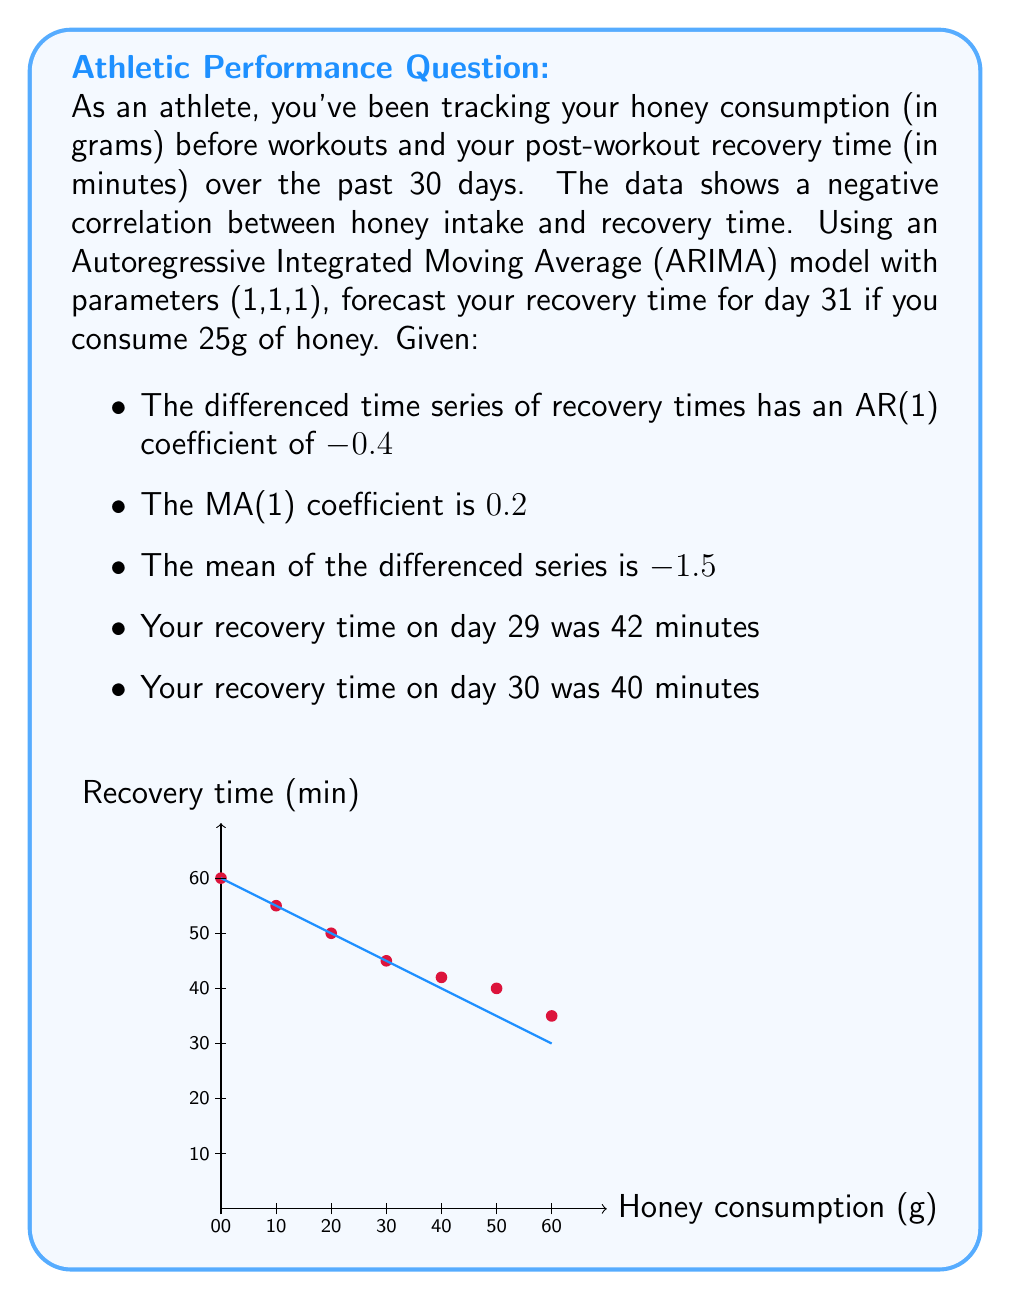Can you solve this math problem? To forecast the recovery time using the ARIMA(1,1,1) model, we'll follow these steps:

1) The general form of an ARIMA(1,1,1) model is:
   $$(1-\phi B)(1-B)y_t = (1+\theta B)\epsilon_t + c$$
   where $\phi$ is the AR(1) coefficient, $\theta$ is the MA(1) coefficient, $B$ is the backshift operator, and $c$ is a constant.

2) Given:
   - AR(1) coefficient $\phi = -0.4$
   - MA(1) coefficient $\theta = 0.2$
   - Mean of differenced series $\mu = -1.5$

3) The constant $c$ is related to the mean of the differenced series:
   $$c = \mu(1-\phi) = -1.5(1-(-0.4)) = -2.1$$

4) Let's denote the recovery time on day $t$ as $y_t$. We need to forecast $y_{31}$.

5) The differenced series is $\nabla y_t = y_t - y_{t-1}$. We're given:
   $y_{29} = 42$, $y_{30} = 40$

6) So, $\nabla y_{30} = y_{30} - y_{29} = 40 - 42 = -2$

7) The ARIMA(1,1,1) forecast equation is:
   $$\nabla y_{31} = -0.4\nabla y_{30} + \epsilon_{31} + 0.2\epsilon_{30} - 2.1$$

8) We don't know $\epsilon_{30}$ and $\epsilon_{31}$, but their expected value is 0, so we'll use 0 in our forecast:
   $$\nabla y_{31} = -0.4(-2) - 2.1 = -1.3$$

9) To get $y_{31}$, we need to "undo" the differencing:
   $$y_{31} = y_{30} + \nabla y_{31} = 40 + (-1.3) = 38.7$$

Therefore, the forecast for recovery time on day 31 is approximately 38.7 minutes.
Answer: 38.7 minutes 